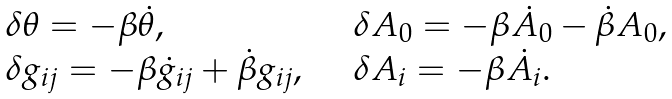Convert formula to latex. <formula><loc_0><loc_0><loc_500><loc_500>\begin{array} { l l } \delta \theta = - \beta \dot { \theta } , & \delta A _ { 0 } = - \beta \dot { A } _ { 0 } - \dot { \beta } A _ { 0 } , \\ \delta g _ { i j } = - \beta \dot { g } _ { i j } + \dot { \beta } g _ { i j } , \quad & \delta A _ { i } = - \beta \dot { A } _ { i } . \end{array}</formula> 